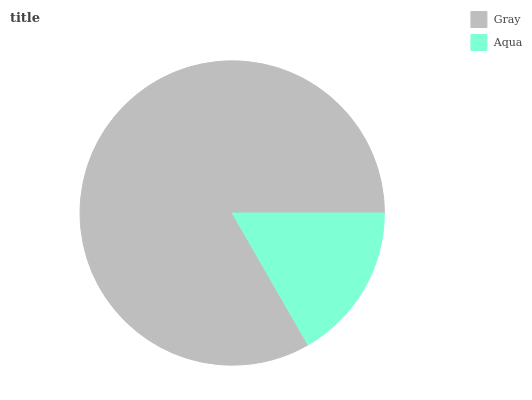Is Aqua the minimum?
Answer yes or no. Yes. Is Gray the maximum?
Answer yes or no. Yes. Is Aqua the maximum?
Answer yes or no. No. Is Gray greater than Aqua?
Answer yes or no. Yes. Is Aqua less than Gray?
Answer yes or no. Yes. Is Aqua greater than Gray?
Answer yes or no. No. Is Gray less than Aqua?
Answer yes or no. No. Is Gray the high median?
Answer yes or no. Yes. Is Aqua the low median?
Answer yes or no. Yes. Is Aqua the high median?
Answer yes or no. No. Is Gray the low median?
Answer yes or no. No. 